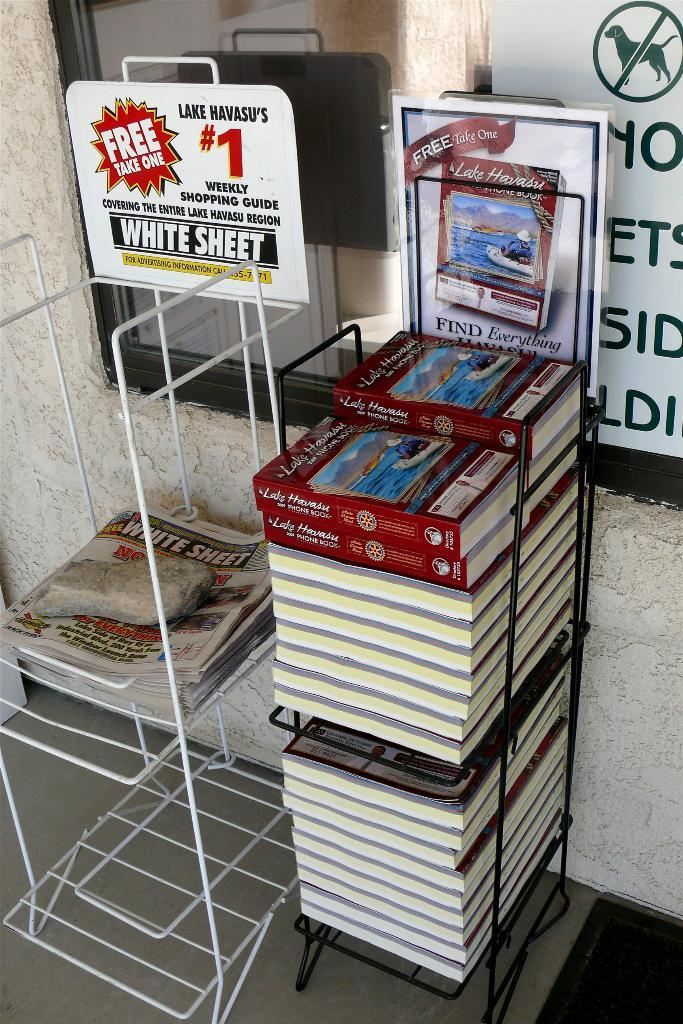<image>
Describe the image concisely. Two news stands, one with 2009 Lake Hawaii telephone books available for pick up. 